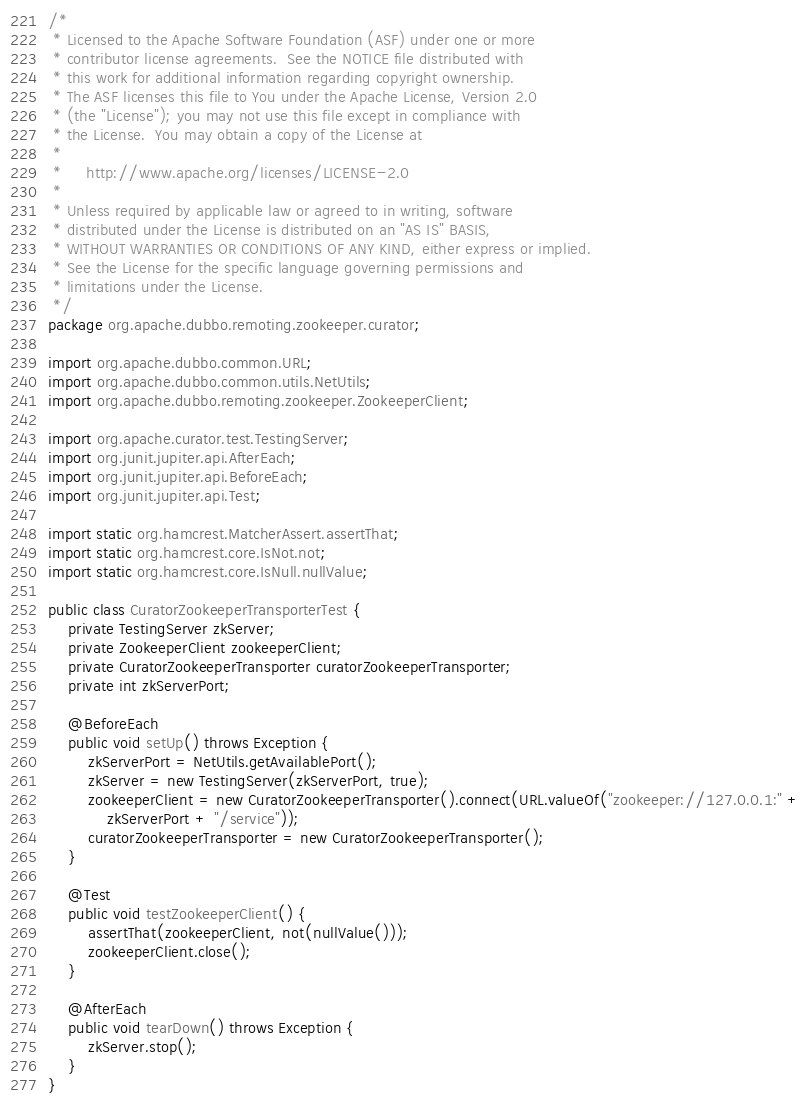<code> <loc_0><loc_0><loc_500><loc_500><_Java_>/*
 * Licensed to the Apache Software Foundation (ASF) under one or more
 * contributor license agreements.  See the NOTICE file distributed with
 * this work for additional information regarding copyright ownership.
 * The ASF licenses this file to You under the Apache License, Version 2.0
 * (the "License"); you may not use this file except in compliance with
 * the License.  You may obtain a copy of the License at
 *
 *     http://www.apache.org/licenses/LICENSE-2.0
 *
 * Unless required by applicable law or agreed to in writing, software
 * distributed under the License is distributed on an "AS IS" BASIS,
 * WITHOUT WARRANTIES OR CONDITIONS OF ANY KIND, either express or implied.
 * See the License for the specific language governing permissions and
 * limitations under the License.
 */
package org.apache.dubbo.remoting.zookeeper.curator;

import org.apache.dubbo.common.URL;
import org.apache.dubbo.common.utils.NetUtils;
import org.apache.dubbo.remoting.zookeeper.ZookeeperClient;

import org.apache.curator.test.TestingServer;
import org.junit.jupiter.api.AfterEach;
import org.junit.jupiter.api.BeforeEach;
import org.junit.jupiter.api.Test;

import static org.hamcrest.MatcherAssert.assertThat;
import static org.hamcrest.core.IsNot.not;
import static org.hamcrest.core.IsNull.nullValue;

public class CuratorZookeeperTransporterTest {
    private TestingServer zkServer;
    private ZookeeperClient zookeeperClient;
    private CuratorZookeeperTransporter curatorZookeeperTransporter;
    private int zkServerPort;

    @BeforeEach
    public void setUp() throws Exception {
        zkServerPort = NetUtils.getAvailablePort();
        zkServer = new TestingServer(zkServerPort, true);
        zookeeperClient = new CuratorZookeeperTransporter().connect(URL.valueOf("zookeeper://127.0.0.1:" +
            zkServerPort + "/service"));
        curatorZookeeperTransporter = new CuratorZookeeperTransporter();
    }

    @Test
    public void testZookeeperClient() {
        assertThat(zookeeperClient, not(nullValue()));
        zookeeperClient.close();
    }

    @AfterEach
    public void tearDown() throws Exception {
        zkServer.stop();
    }
}
</code> 